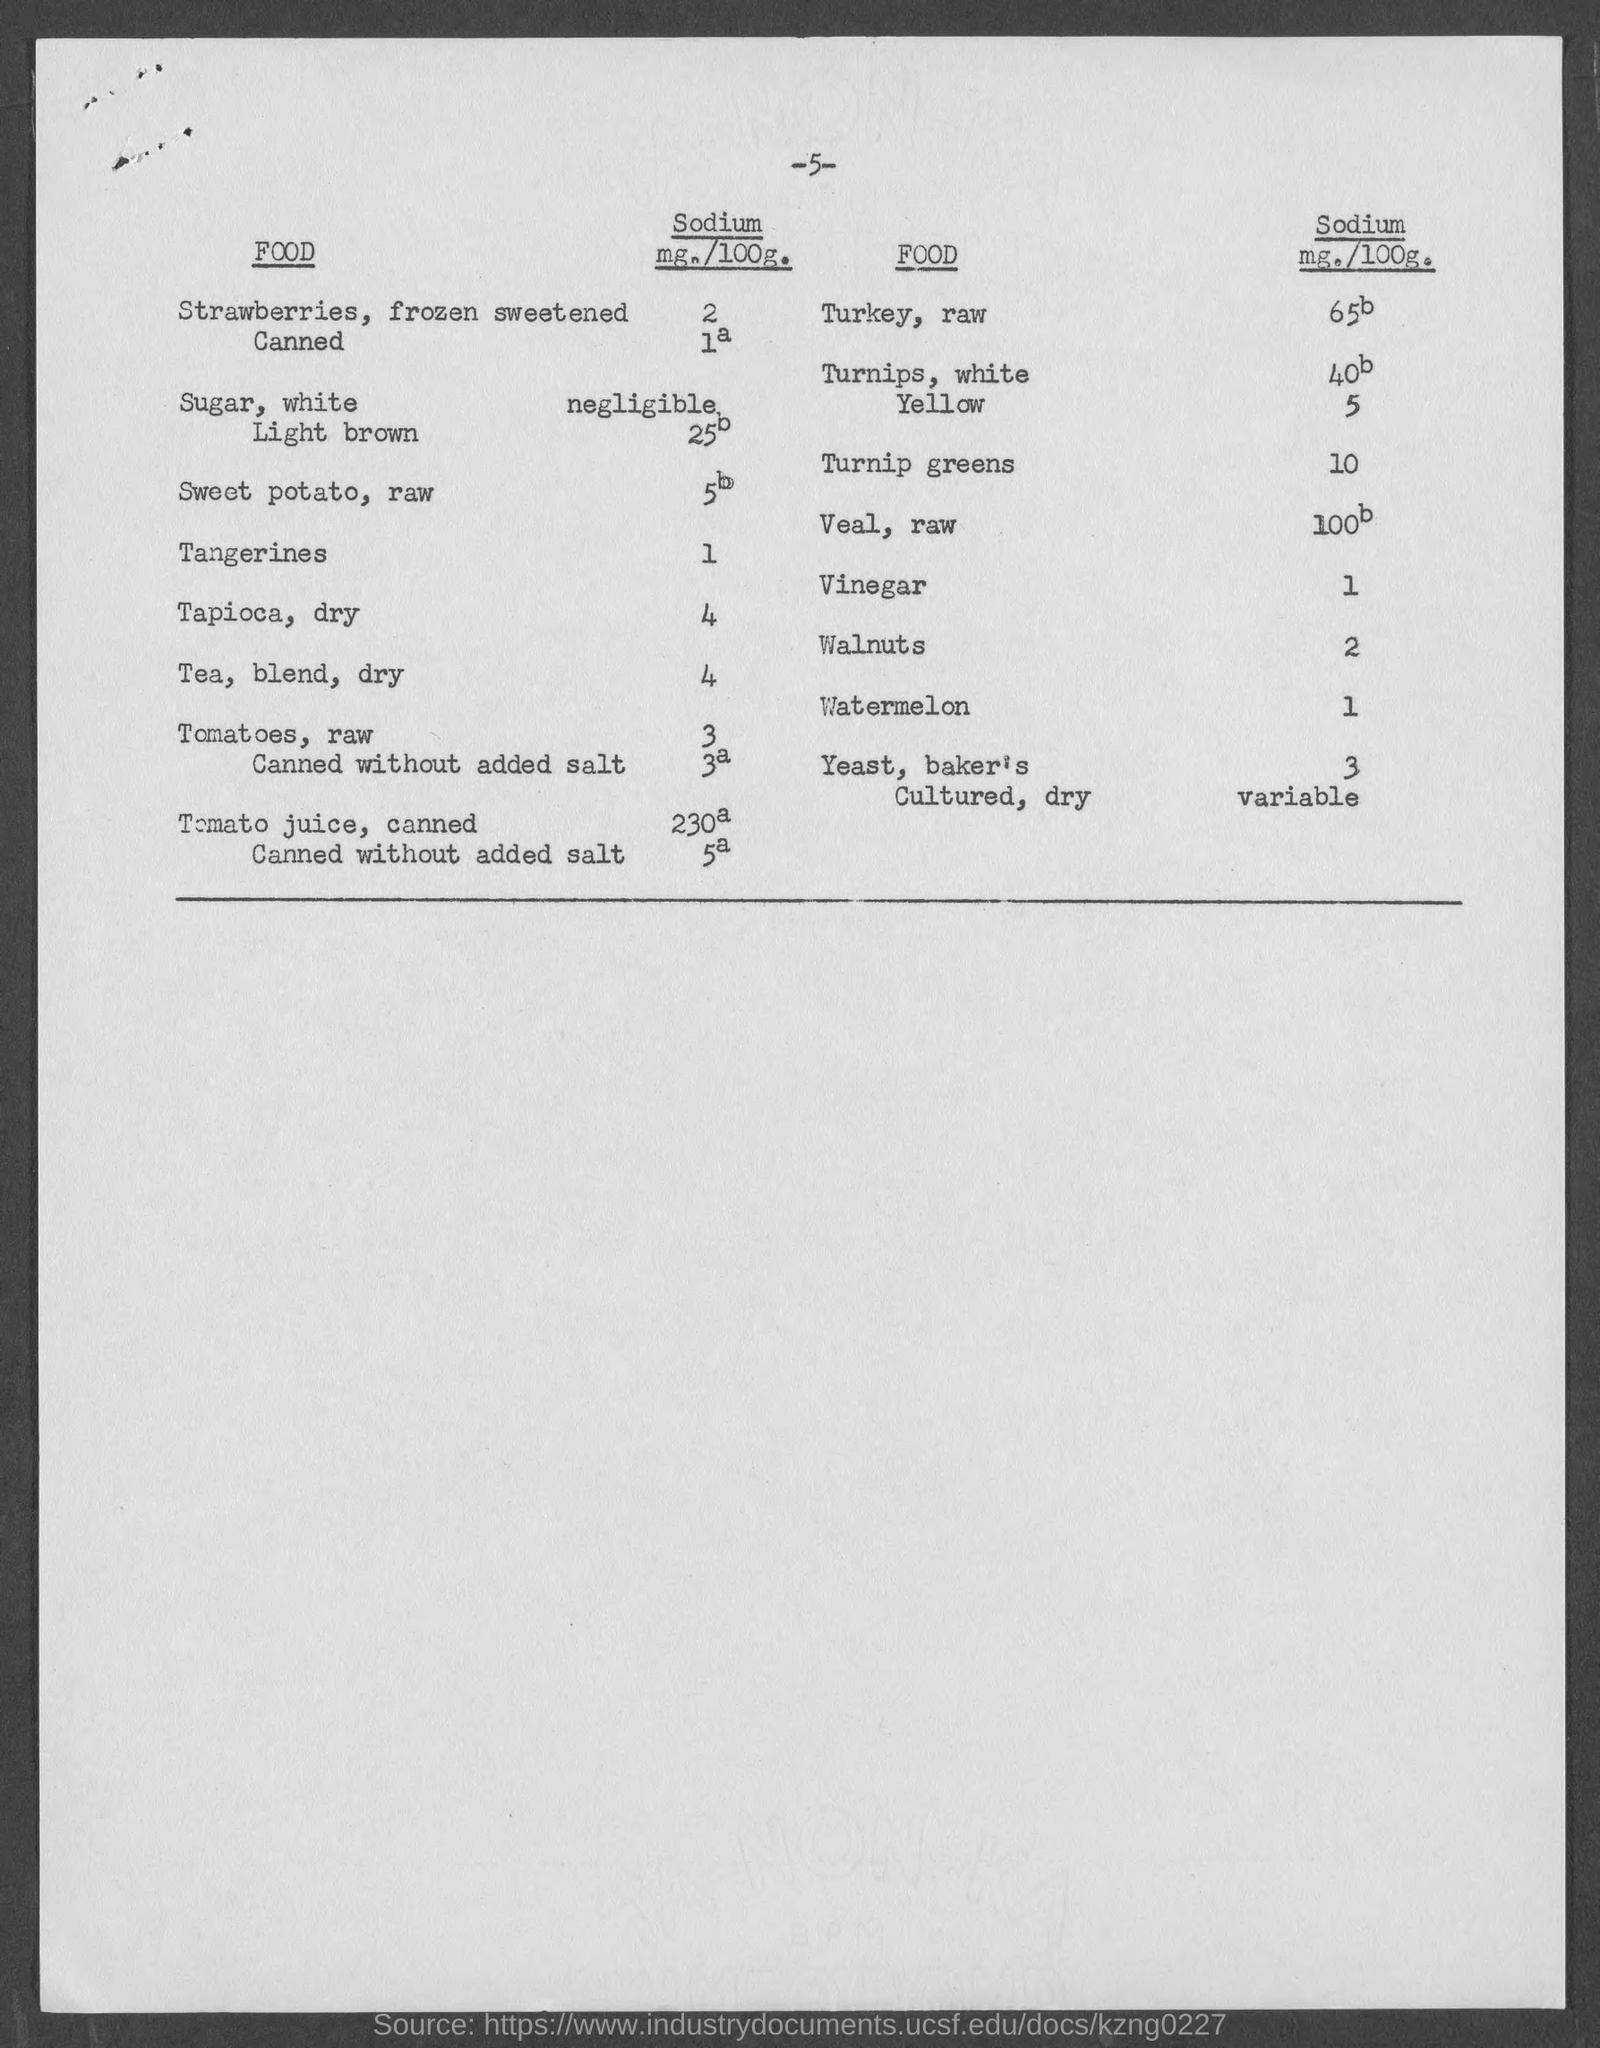Point out several critical features in this image. The amount of sodium present in vinegar is 1. The amount of sodium present in raw tomatoes is 3. The amount of sodium present in watermelon is 10 milligrams per one hundred grams. The amount of sodium present in tapioca, dry, is 4. The amount of sodium present in walnuts is approximately 2 grams per 100 grams of weight. 